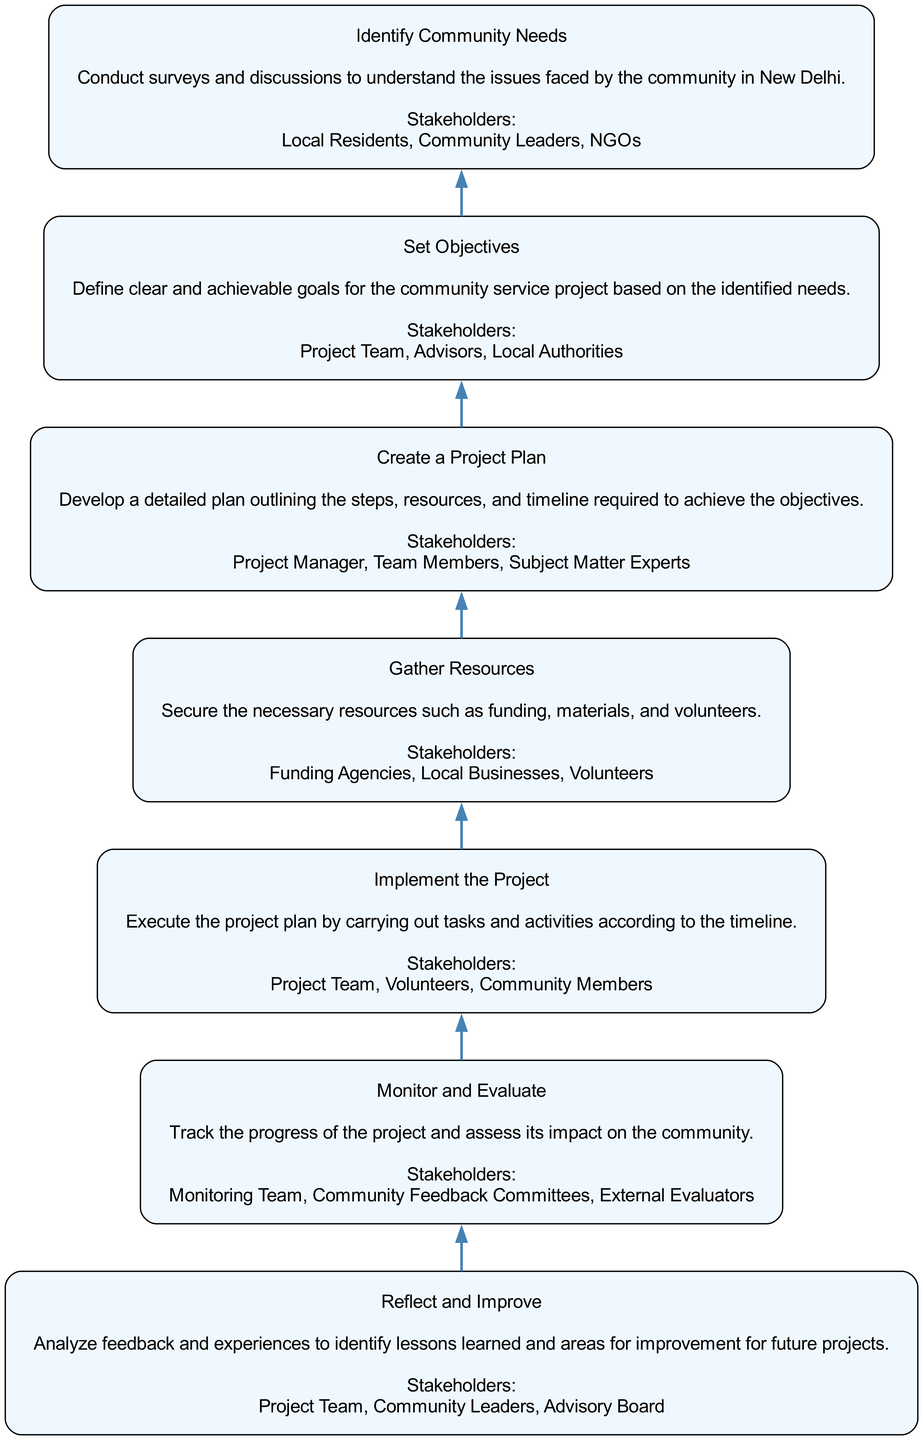What is the first stage in the diagram? The diagram starts with the bottom node, which is labeled "Identify Community Needs." This indicates that it is the initial stage of the implementation process for the community service project.
Answer: Identify Community Needs How many stakeholders are involved in the "Gather Resources" stage? The "Gather Resources" stage lists three stakeholders: "Funding Agencies," "Local Businesses," and "Volunteers." Therefore, the count of stakeholders in this stage is three.
Answer: Three What is the primary activity in the "Monitor and Evaluate" stage? In the "Monitor and Evaluate" stage, the primary activity mentioned is to "Track the progress of the project and assess its impact on the community." This succinctly outlines what occurs at this stage.
Answer: Track the progress Which stage directly follows "Create a Project Plan"? "Gather Resources" follows "Create a Project Plan" in the flow of the diagram, indicating the sequence of actions to be taken in the project implementation.
Answer: Gather Resources Who are the stakeholders involved in the final stage? The final stage "Reflect and Improve" lists three stakeholders: "Project Team," "Community Leaders," and "Advisory Board." These entities are involved in analyzing feedback and experiences for improvement.
Answer: Project Team, Community Leaders, Advisory Board What is the relationship between "Set Objectives" and "Identify Community Needs"? "Set Objectives" is a subsequent stage that relies on input from "Identify Community Needs." The objectives defined in the second stage are based on the needs uncovered in the first stage.
Answer: "Set Objectives" follows "Identify Community Needs" What is the main purpose of the "Implement the Project" stage? The main purpose described for "Implement the Project" is to "Execute the project plan by carrying out tasks and activities according to the timeline." This specifies the focus of this stage in the project lifecycle.
Answer: Execute the project plan How many total stages are there in the diagram? The diagram includes a total of seven stages, as listed sequentially from "Identify Community Needs" to "Reflect and Improve." This count is reached by simply enumerating the stages presented.
Answer: Seven What stage would come before "Reflect and Improve"? The stage that comes directly before "Reflect and Improve" in the flow is "Monitor and Evaluate," indicating that assessment precedes reflection in the process.
Answer: Monitor and Evaluate 